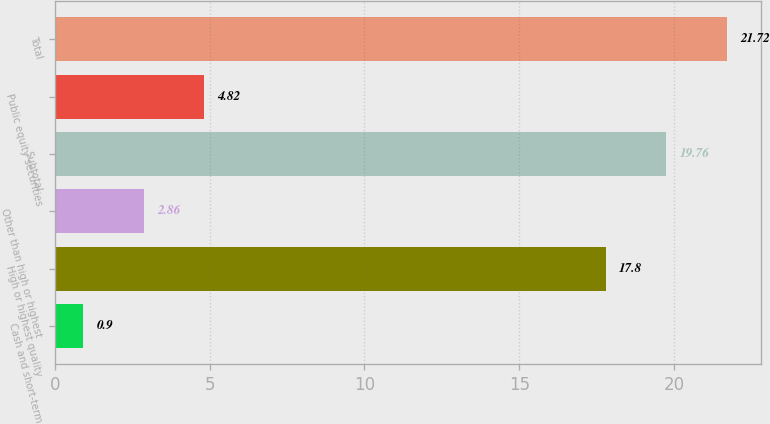Convert chart to OTSL. <chart><loc_0><loc_0><loc_500><loc_500><bar_chart><fcel>Cash and short-term<fcel>High or highest quality<fcel>Other than high or highest<fcel>Subtotal<fcel>Public equity securities<fcel>Total<nl><fcel>0.9<fcel>17.8<fcel>2.86<fcel>19.76<fcel>4.82<fcel>21.72<nl></chart> 